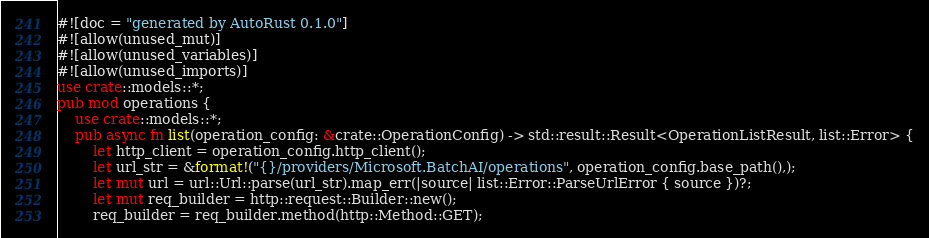Convert code to text. <code><loc_0><loc_0><loc_500><loc_500><_Rust_>#![doc = "generated by AutoRust 0.1.0"]
#![allow(unused_mut)]
#![allow(unused_variables)]
#![allow(unused_imports)]
use crate::models::*;
pub mod operations {
    use crate::models::*;
    pub async fn list(operation_config: &crate::OperationConfig) -> std::result::Result<OperationListResult, list::Error> {
        let http_client = operation_config.http_client();
        let url_str = &format!("{}/providers/Microsoft.BatchAI/operations", operation_config.base_path(),);
        let mut url = url::Url::parse(url_str).map_err(|source| list::Error::ParseUrlError { source })?;
        let mut req_builder = http::request::Builder::new();
        req_builder = req_builder.method(http::Method::GET);</code> 